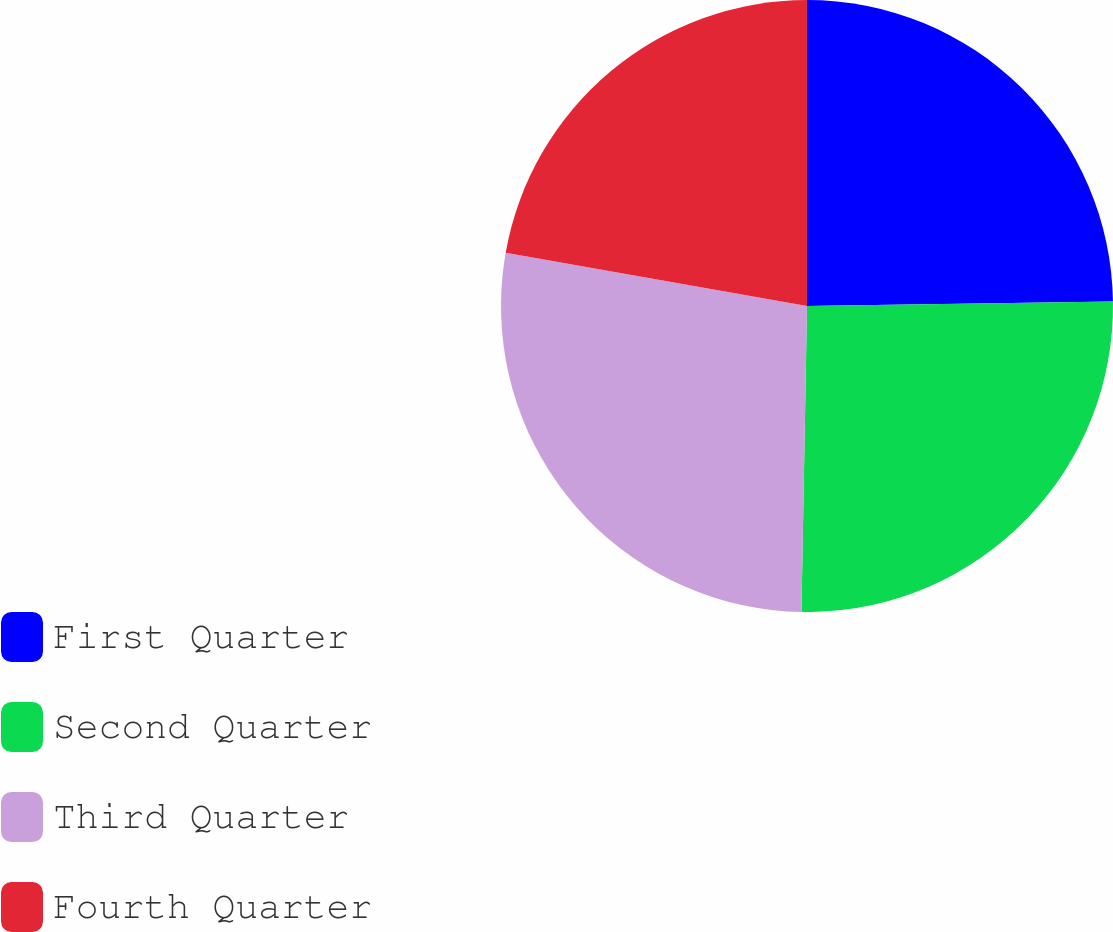<chart> <loc_0><loc_0><loc_500><loc_500><pie_chart><fcel>First Quarter<fcel>Second Quarter<fcel>Third Quarter<fcel>Fourth Quarter<nl><fcel>24.76%<fcel>25.53%<fcel>27.5%<fcel>22.21%<nl></chart> 